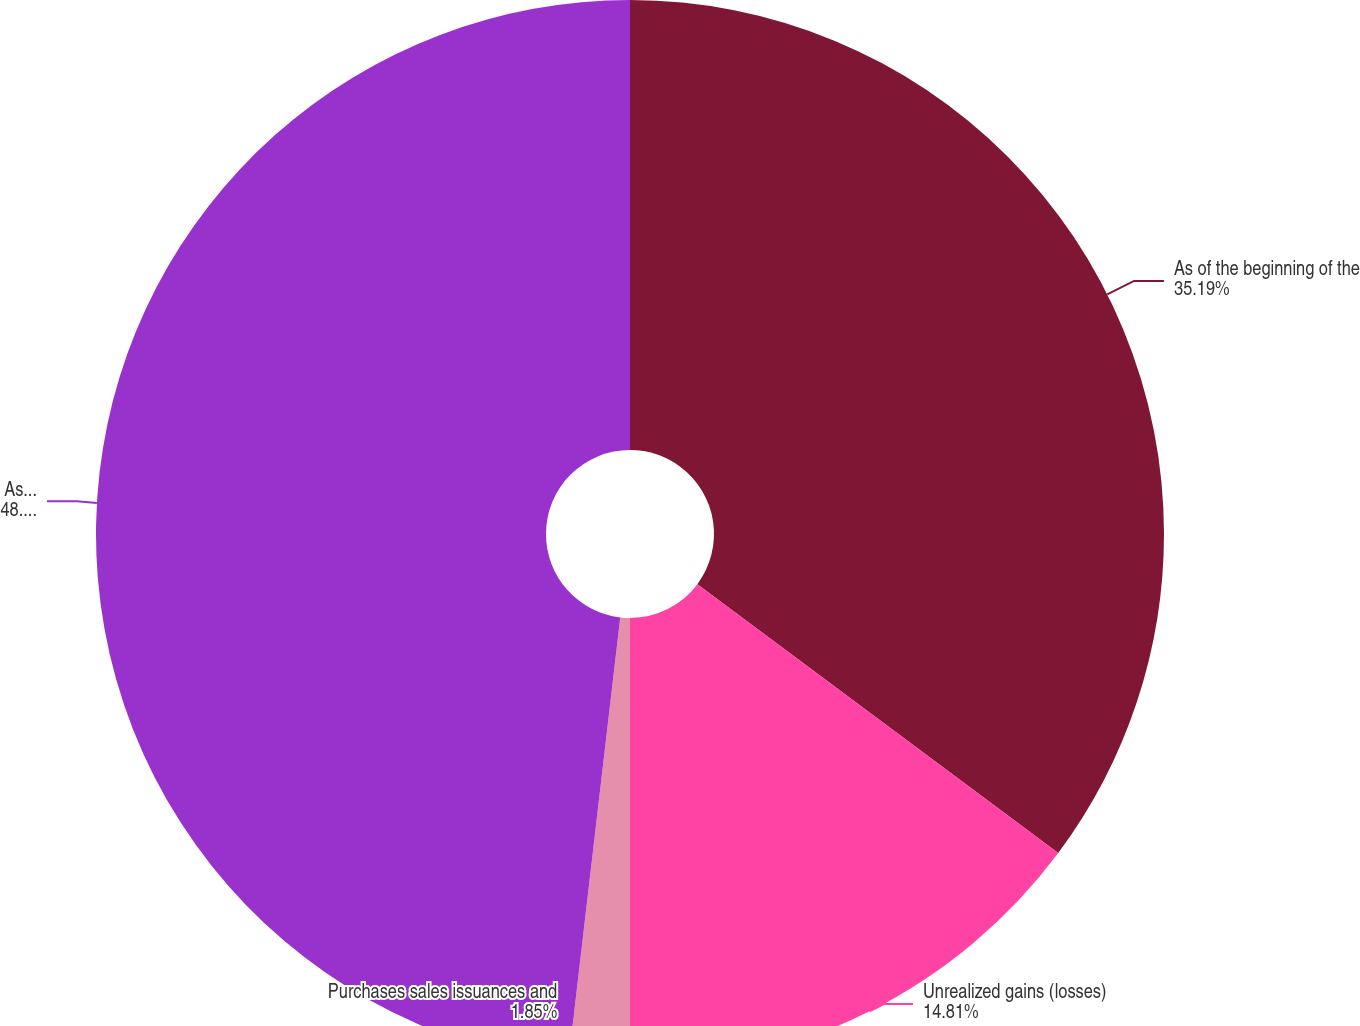Convert chart to OTSL. <chart><loc_0><loc_0><loc_500><loc_500><pie_chart><fcel>As of the beginning of the<fcel>Unrealized gains (losses)<fcel>Purchases sales issuances and<fcel>Asoftheendoftheyear<nl><fcel>35.19%<fcel>14.81%<fcel>1.85%<fcel>48.15%<nl></chart> 